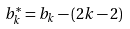<formula> <loc_0><loc_0><loc_500><loc_500>b ^ { * } _ { k } = b _ { k } - ( 2 k - 2 )</formula> 